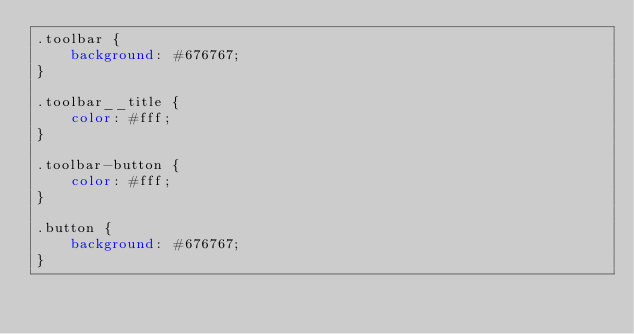Convert code to text. <code><loc_0><loc_0><loc_500><loc_500><_CSS_>.toolbar {
	background: #676767;
}

.toolbar__title {
	color: #fff;
}

.toolbar-button {
	color: #fff;
}

.button {
	background: #676767;
}</code> 